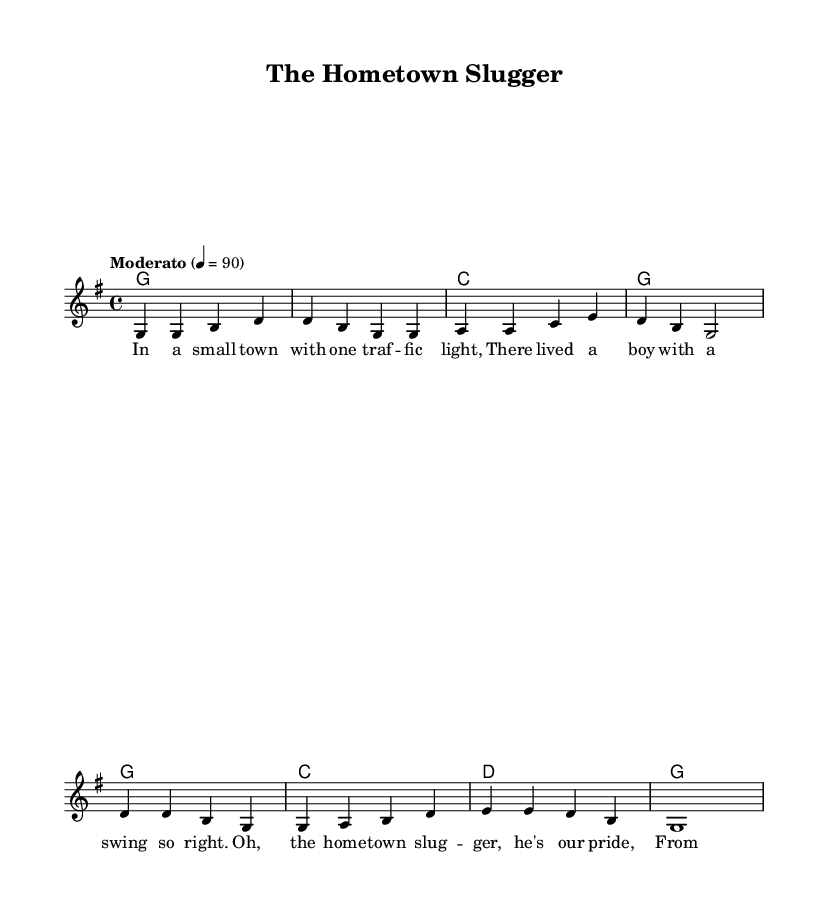What is the key signature of this music? The key signature is G major, which has one sharp (F sharp). This is indicated at the beginning of the score.
Answer: G major What is the time signature? The time signature is 4/4, which means there are four beats in each measure. This is found at the beginning of the music staff.
Answer: 4/4 What is the tempo marking? The tempo marking is "Moderato," which suggests a moderate speed of 90 beats per minute. This is written just under the initial clef sign in the score.
Answer: Moderato How many measures are in the verse section? The verse section contains four measures as seen in the melody line, which has a total of eight beats corresponding to the lyrics. By counting the vertical lines separating the music notation, we see there are four measures for the verse.
Answer: Four What lyrical theme is presented in the song? The lyrical theme revolves around a small-town sports hero, specifically referring to a boy who is called the "hometown slugger." This is evident in the first verse provided.
Answer: Small-town sports hero How do the harmonies change in the chorus compared to the verse? In the verse, the harmonies primarily use G and C chords, while in the chorus, it incorporates D chord along with G and C. Observing the chord progression in each section reveals this difference.
Answer: G, C, D What role does the lead voice play in this folk ballad? The lead voice carries the melody, telling the story of the small-town slugger, which is typical for folk ballads aimed at narrating personal stories. This function is clear from the presence of the melody line designated as "lead."
Answer: Melody 